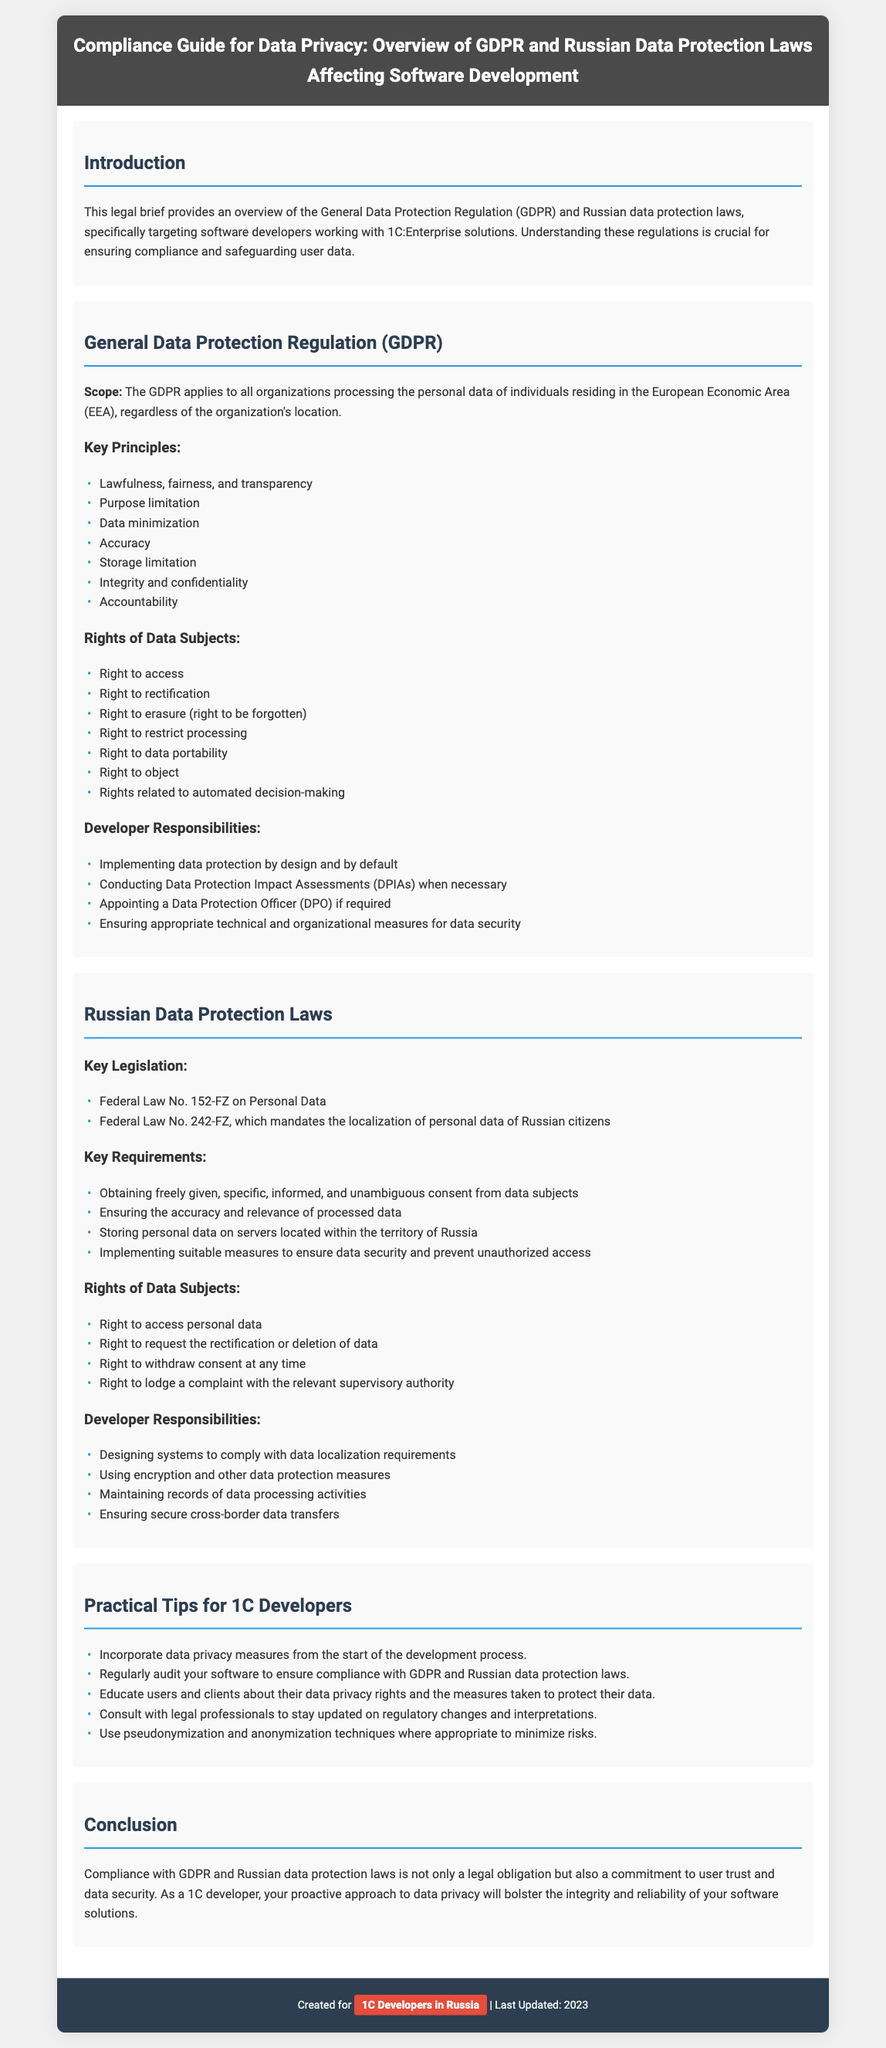What does GDPR stand for? GDPR is an abbreviation mentioned in the document that stands for General Data Protection Regulation.
Answer: General Data Protection Regulation Who needs to appoint a Data Protection Officer (DPO)? The document states that developers are responsible for appointing a DPO if required, thus organizations processing personal data need to assess this necessity.
Answer: If required What is one of the rights of data subjects under the GDPR? The document lists several rights, one of which is the right to access personal data.
Answer: Right to access What is the key legislation for Russian data protection? The document mentions Federal Law No. 152-FZ on Personal Data as a key legislation for Russian data protection.
Answer: Federal Law No. 152-FZ on Personal Data What must developers ensure according to the Russian Data Protection Laws? The document specifies that developers must ensure the accuracy and relevance of processed data under Russian data protection laws.
Answer: Accuracy and relevance How many key principles are there under GDPR? The document outlines seven key principles of GDPR, which are crucial for compliance in software development.
Answer: Seven What should developers do with personal data according to Russian laws? Developers must ensure that personal data is stored on servers located within the territory of Russia according to the law specified in the document.
Answer: Within the territory of Russia What is a practical tip given for 1C Developers regarding data privacy? One practical tip for 1C Developers is to incorporate data privacy measures from the start of the development process.
Answer: Incorporate data privacy measures from the start What will proactive compliance with data protection laws help as mentioned in the conclusion? The conclusion emphasizes that compliance with these laws will bolster user trust and data security within software solutions.
Answer: User trust and data security 